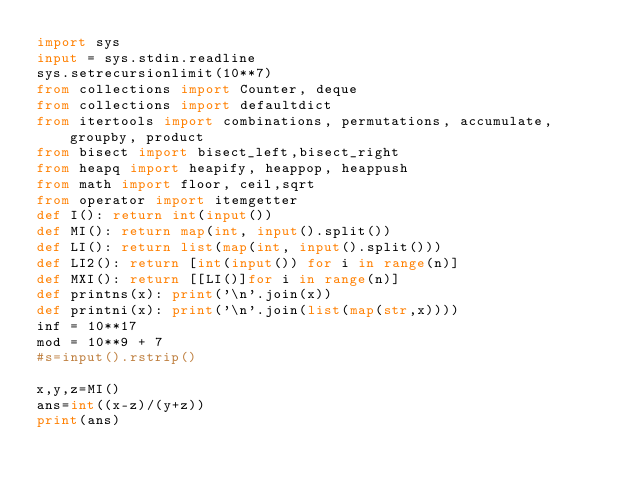<code> <loc_0><loc_0><loc_500><loc_500><_Python_>import sys
input = sys.stdin.readline
sys.setrecursionlimit(10**7)
from collections import Counter, deque
from collections import defaultdict
from itertools import combinations, permutations, accumulate, groupby, product
from bisect import bisect_left,bisect_right
from heapq import heapify, heappop, heappush
from math import floor, ceil,sqrt
from operator import itemgetter
def I(): return int(input())
def MI(): return map(int, input().split())
def LI(): return list(map(int, input().split()))
def LI2(): return [int(input()) for i in range(n)]
def MXI(): return [[LI()]for i in range(n)]
def printns(x): print('\n'.join(x))
def printni(x): print('\n'.join(list(map(str,x))))
inf = 10**17
mod = 10**9 + 7
#s=input().rstrip()

x,y,z=MI()
ans=int((x-z)/(y+z))
print(ans)
</code> 